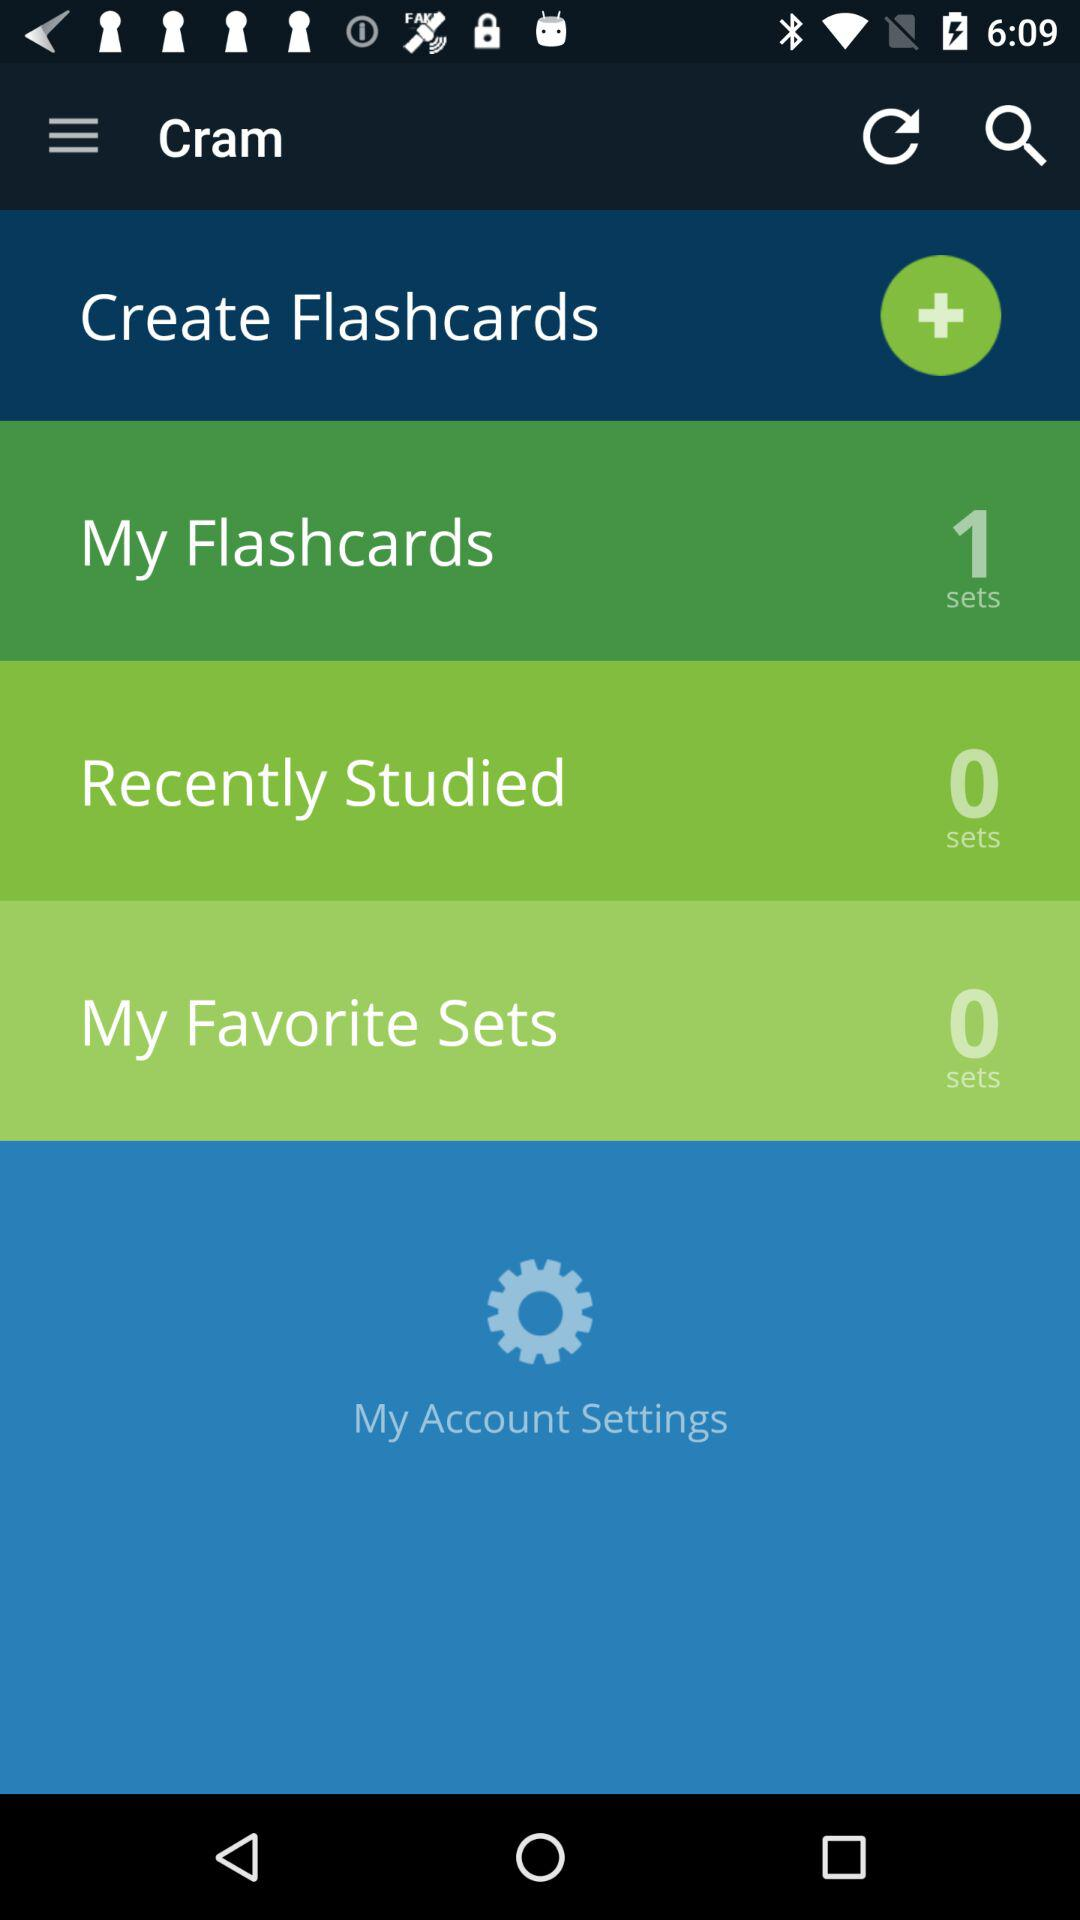How many sets are there in "My Favorite Sets"? There are 0 sets in "My Favorite Sets". 